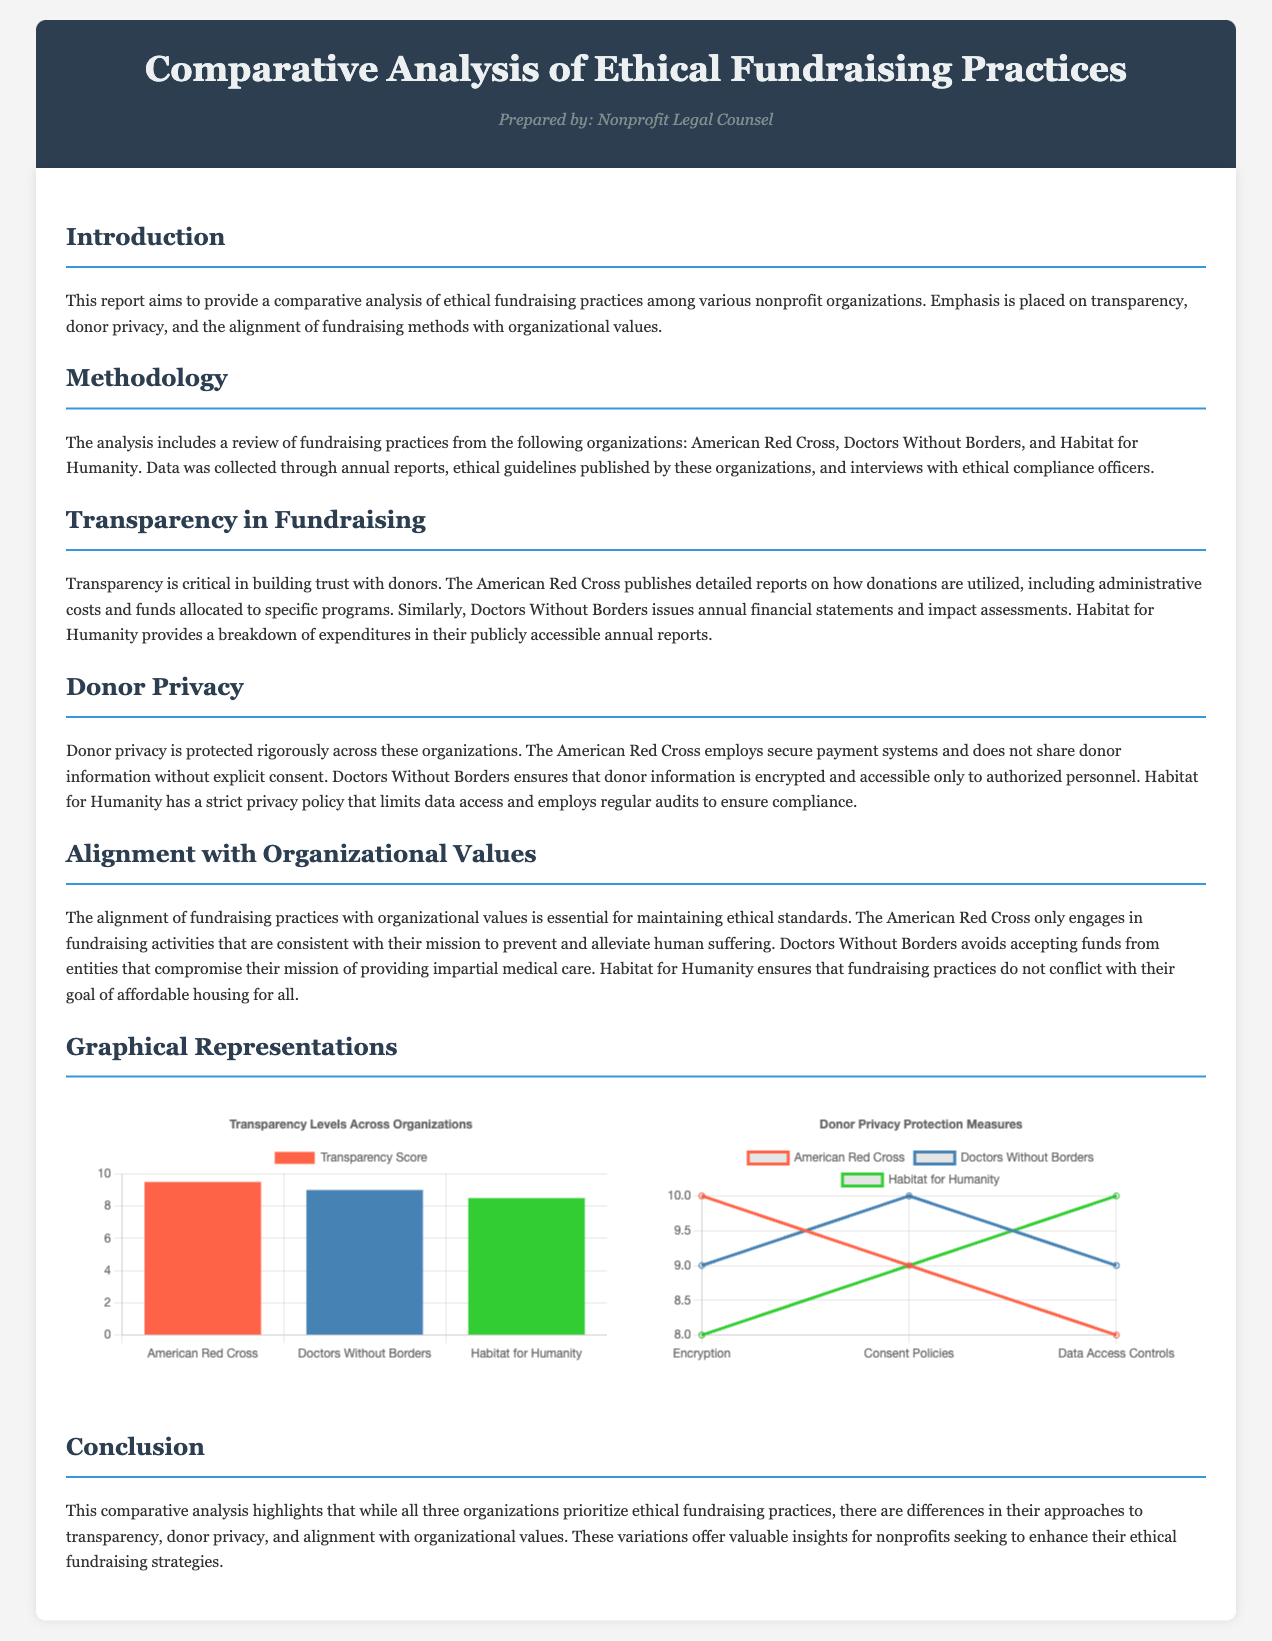What are the three organizations analyzed in the report? The organizations analyzed are named in the methodology section of the report.
Answer: American Red Cross, Doctors Without Borders, Habitat for Humanity What is the transparency score for the American Red Cross? The transparency score is found in the graphical representation section of the report.
Answer: 9.5 Which organization has the highest score in donor privacy consent policies? This information is summarized in the privacy chart, comparing the measures across organizations.
Answer: Doctors Without Borders What method of fundraising does Habitat for Humanity ensure to align with their mission? The alignment with organizational values section outlines this approach to fundraising practices.
Answer: Affordable housing for all What type of chart is used to represent donor privacy measures? The type of chart is mentioned in the graphical representations section of the report.
Answer: Line chart 